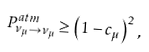<formula> <loc_0><loc_0><loc_500><loc_500>P ^ { a t m } _ { \nu _ { \mu } \to \nu _ { \mu } } \geq \left ( 1 - c _ { \mu } \right ) ^ { 2 } \, ,</formula> 